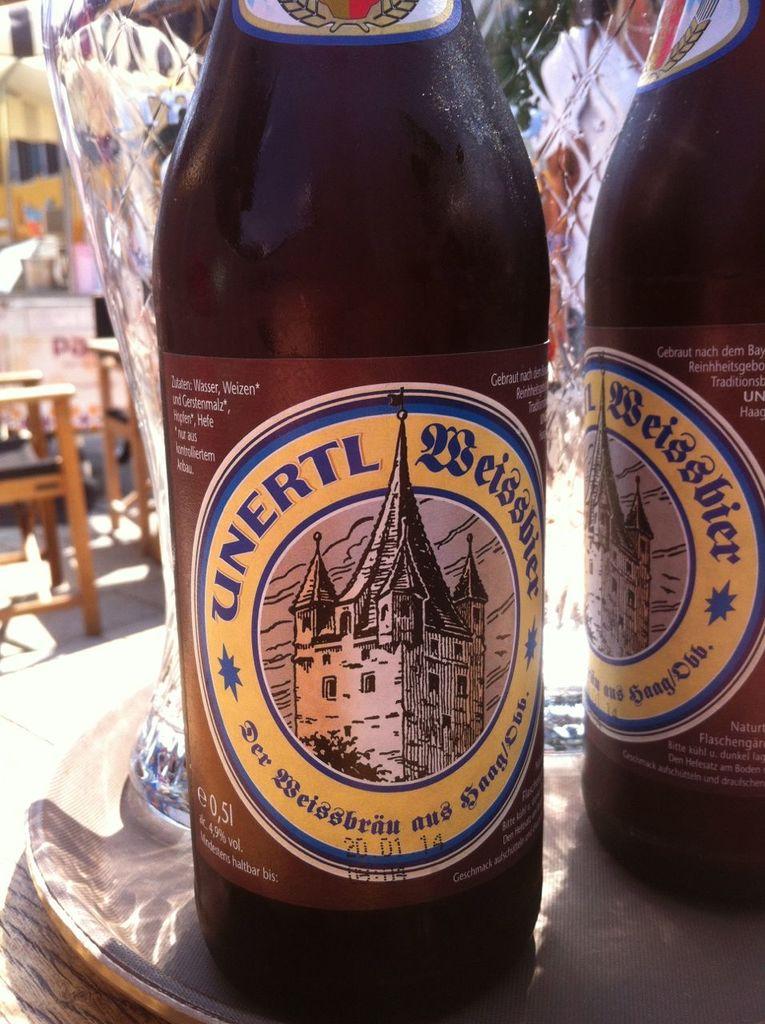What kind of beer is this?
Your answer should be compact. Unertl weissbier. What brand of beer is this?
Give a very brief answer. Unertl. 